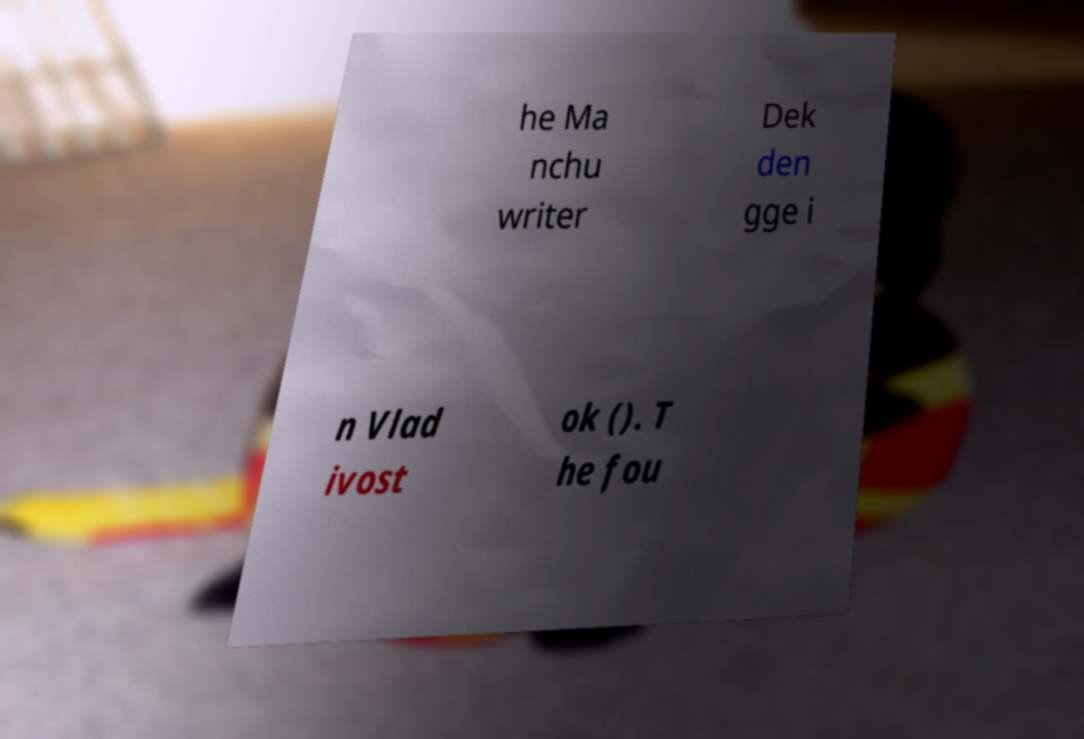What messages or text are displayed in this image? I need them in a readable, typed format. he Ma nchu writer Dek den gge i n Vlad ivost ok (). T he fou 